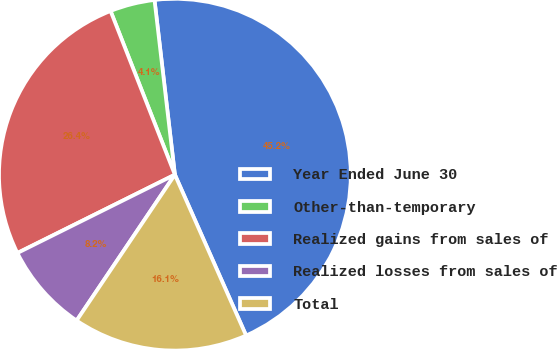Convert chart. <chart><loc_0><loc_0><loc_500><loc_500><pie_chart><fcel>Year Ended June 30<fcel>Other-than-temporary<fcel>Realized gains from sales of<fcel>Realized losses from sales of<fcel>Total<nl><fcel>45.22%<fcel>4.11%<fcel>26.39%<fcel>8.22%<fcel>16.07%<nl></chart> 